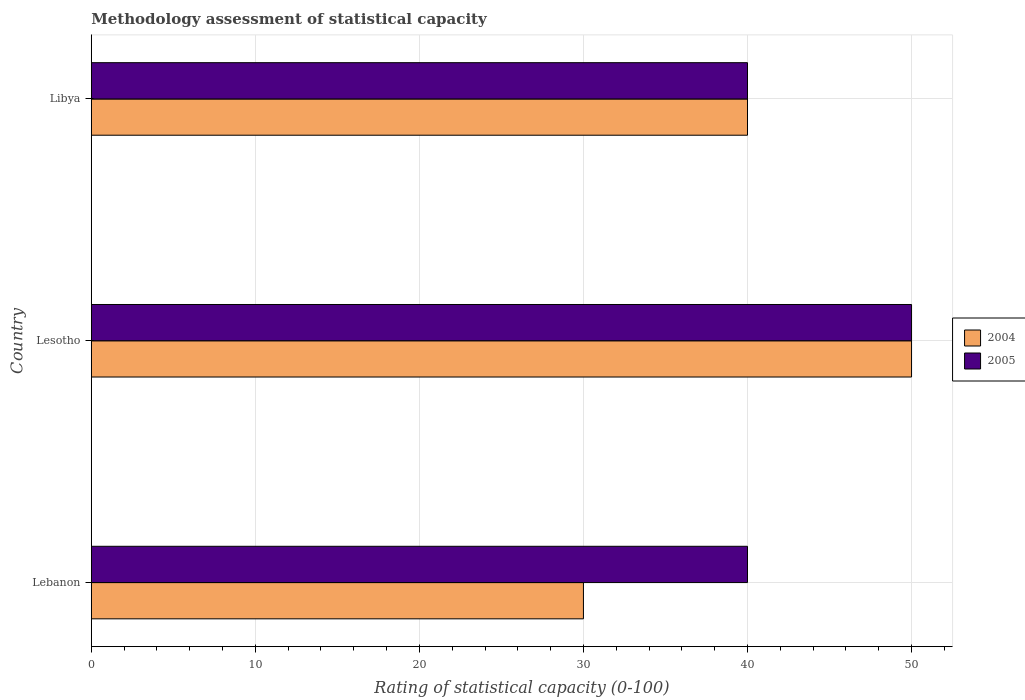Are the number of bars on each tick of the Y-axis equal?
Your answer should be compact. Yes. How many bars are there on the 2nd tick from the top?
Your response must be concise. 2. What is the label of the 3rd group of bars from the top?
Ensure brevity in your answer.  Lebanon. What is the rating of statistical capacity in 2005 in Lesotho?
Ensure brevity in your answer.  50. Across all countries, what is the maximum rating of statistical capacity in 2004?
Ensure brevity in your answer.  50. In which country was the rating of statistical capacity in 2005 maximum?
Your answer should be very brief. Lesotho. In which country was the rating of statistical capacity in 2005 minimum?
Provide a short and direct response. Lebanon. What is the total rating of statistical capacity in 2005 in the graph?
Offer a terse response. 130. What is the difference between the rating of statistical capacity in 2005 in Libya and the rating of statistical capacity in 2004 in Lesotho?
Your answer should be very brief. -10. What is the average rating of statistical capacity in 2005 per country?
Offer a terse response. 43.33. Is the rating of statistical capacity in 2004 in Lebanon less than that in Libya?
Give a very brief answer. Yes. What is the difference between the highest and the second highest rating of statistical capacity in 2004?
Your answer should be very brief. 10. In how many countries, is the rating of statistical capacity in 2004 greater than the average rating of statistical capacity in 2004 taken over all countries?
Give a very brief answer. 1. Is the sum of the rating of statistical capacity in 2004 in Lebanon and Libya greater than the maximum rating of statistical capacity in 2005 across all countries?
Your answer should be very brief. Yes. What does the 1st bar from the top in Libya represents?
Your response must be concise. 2005. What does the 1st bar from the bottom in Libya represents?
Offer a very short reply. 2004. How many bars are there?
Give a very brief answer. 6. Are all the bars in the graph horizontal?
Your answer should be very brief. Yes. How many countries are there in the graph?
Give a very brief answer. 3. Does the graph contain any zero values?
Offer a very short reply. No. Does the graph contain grids?
Keep it short and to the point. Yes. What is the title of the graph?
Ensure brevity in your answer.  Methodology assessment of statistical capacity. What is the label or title of the X-axis?
Provide a short and direct response. Rating of statistical capacity (0-100). What is the Rating of statistical capacity (0-100) in 2004 in Lebanon?
Keep it short and to the point. 30. What is the Rating of statistical capacity (0-100) of 2005 in Lebanon?
Ensure brevity in your answer.  40. What is the Rating of statistical capacity (0-100) in 2004 in Lesotho?
Make the answer very short. 50. What is the Rating of statistical capacity (0-100) of 2004 in Libya?
Your response must be concise. 40. What is the Rating of statistical capacity (0-100) in 2005 in Libya?
Keep it short and to the point. 40. Across all countries, what is the maximum Rating of statistical capacity (0-100) in 2004?
Offer a very short reply. 50. What is the total Rating of statistical capacity (0-100) in 2004 in the graph?
Your response must be concise. 120. What is the total Rating of statistical capacity (0-100) in 2005 in the graph?
Provide a succinct answer. 130. What is the difference between the Rating of statistical capacity (0-100) of 2004 in Lebanon and that in Lesotho?
Provide a short and direct response. -20. What is the difference between the Rating of statistical capacity (0-100) in 2004 in Lebanon and that in Libya?
Ensure brevity in your answer.  -10. What is the difference between the Rating of statistical capacity (0-100) in 2005 in Lebanon and that in Libya?
Your answer should be very brief. 0. What is the difference between the Rating of statistical capacity (0-100) of 2004 in Lesotho and that in Libya?
Give a very brief answer. 10. What is the difference between the Rating of statistical capacity (0-100) of 2004 in Lebanon and the Rating of statistical capacity (0-100) of 2005 in Lesotho?
Keep it short and to the point. -20. What is the difference between the Rating of statistical capacity (0-100) of 2004 in Lebanon and the Rating of statistical capacity (0-100) of 2005 in Libya?
Ensure brevity in your answer.  -10. What is the average Rating of statistical capacity (0-100) of 2005 per country?
Ensure brevity in your answer.  43.33. What is the difference between the Rating of statistical capacity (0-100) of 2004 and Rating of statistical capacity (0-100) of 2005 in Lebanon?
Offer a terse response. -10. What is the difference between the Rating of statistical capacity (0-100) in 2004 and Rating of statistical capacity (0-100) in 2005 in Libya?
Keep it short and to the point. 0. What is the ratio of the Rating of statistical capacity (0-100) of 2004 in Lebanon to that in Libya?
Give a very brief answer. 0.75. What is the ratio of the Rating of statistical capacity (0-100) of 2005 in Lebanon to that in Libya?
Your response must be concise. 1. What is the difference between the highest and the lowest Rating of statistical capacity (0-100) of 2004?
Provide a short and direct response. 20. 